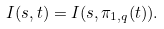<formula> <loc_0><loc_0><loc_500><loc_500>I ( s , t ) = I ( s , \pi _ { 1 , q } ( t ) ) .</formula> 